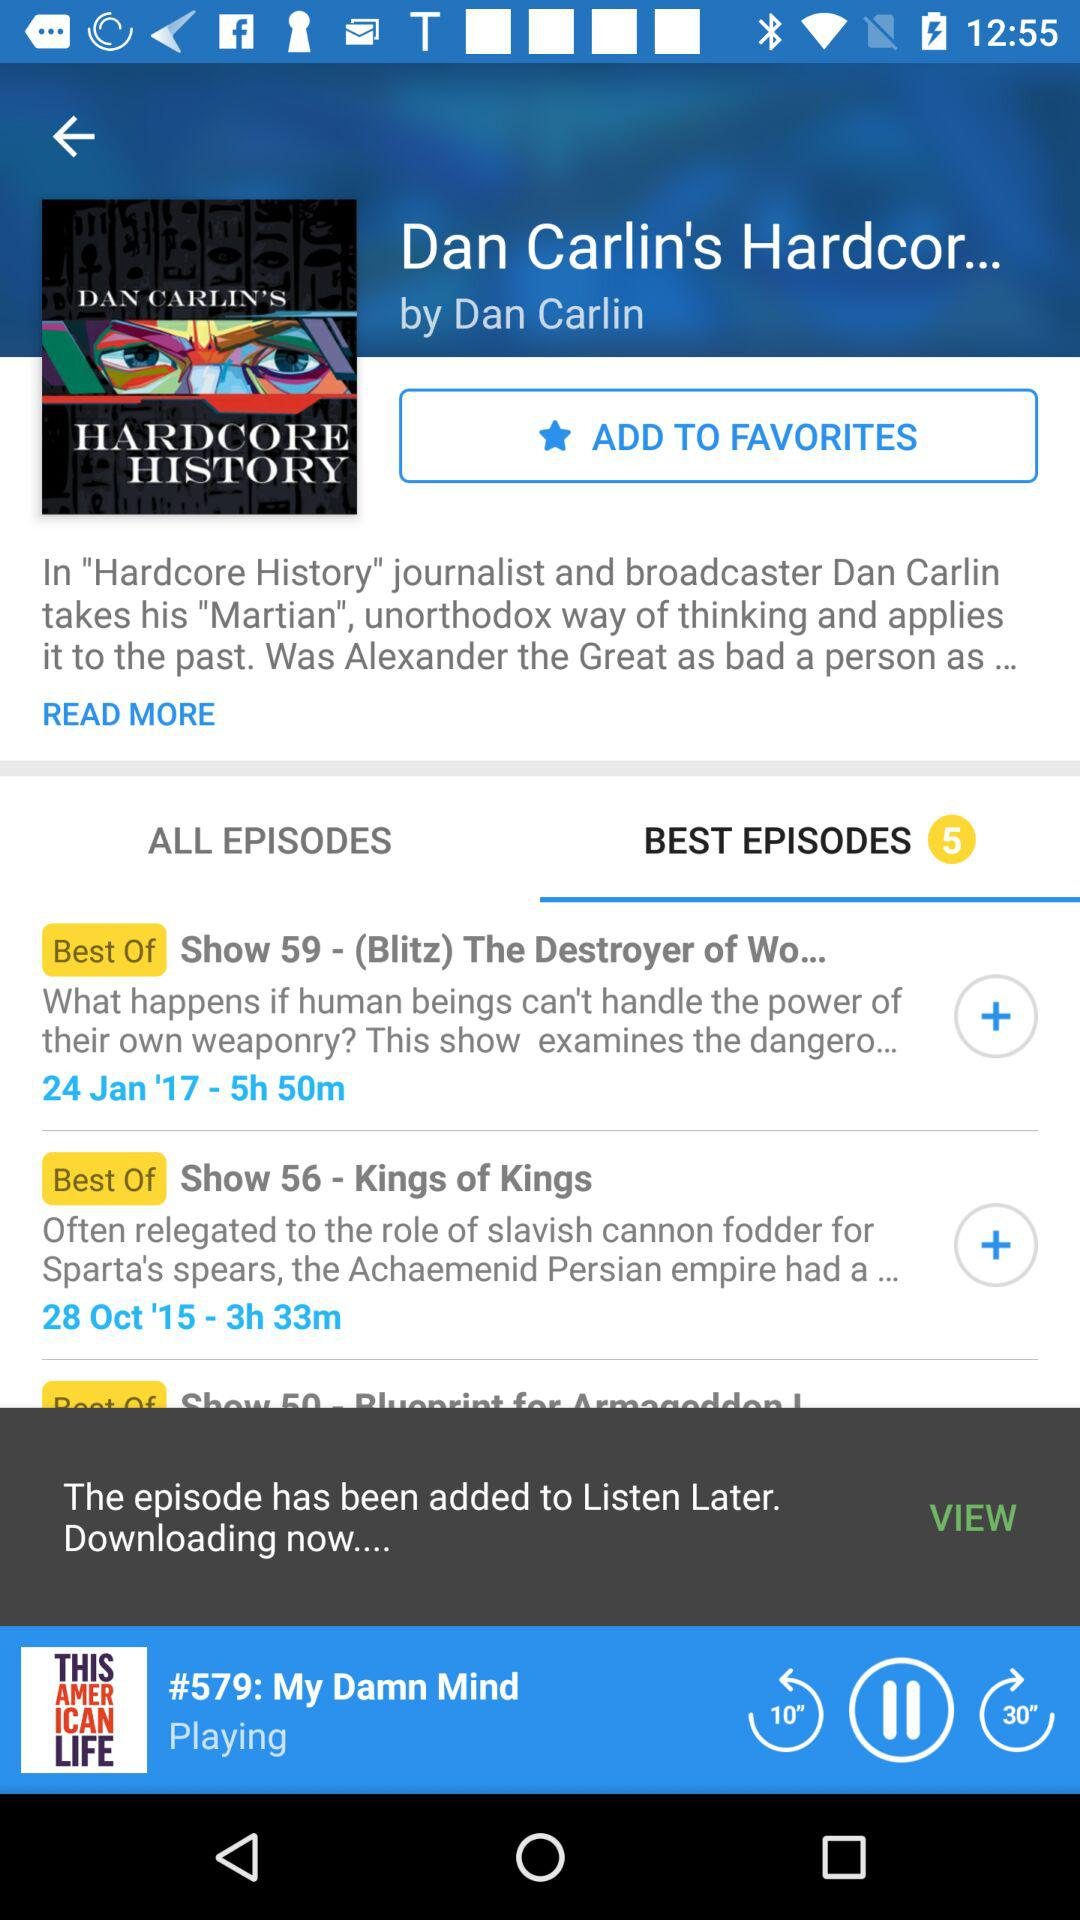Who is the broadcaster of "Hardcore History"? The broadcaster is Dan Carlin. 